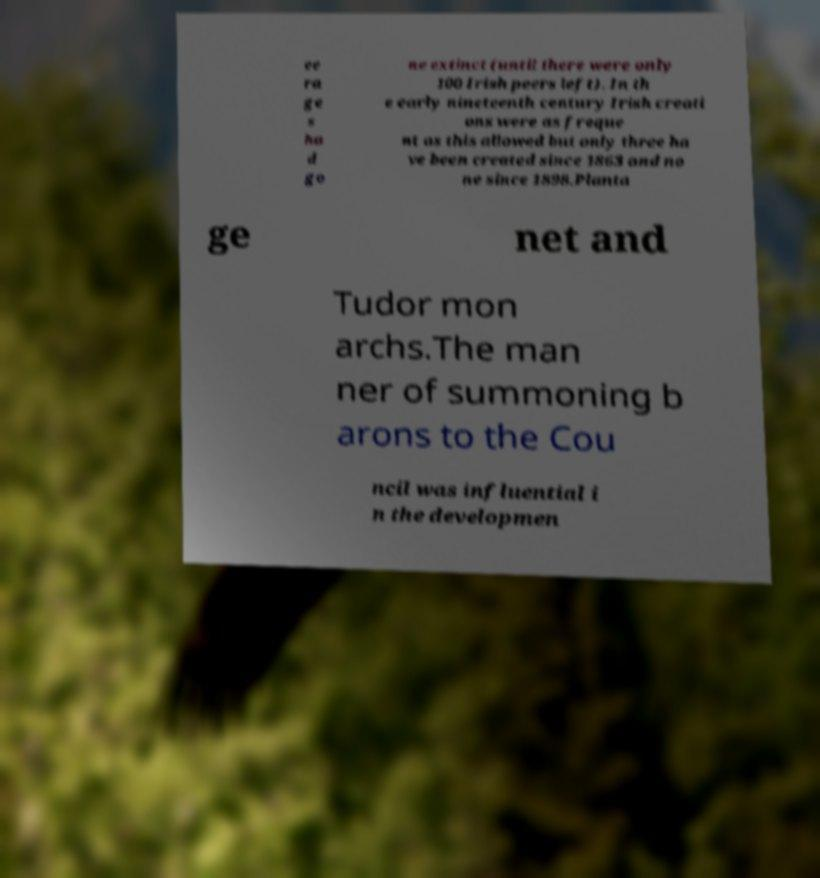Could you assist in decoding the text presented in this image and type it out clearly? ee ra ge s ha d go ne extinct (until there were only 100 Irish peers left). In th e early nineteenth century Irish creati ons were as freque nt as this allowed but only three ha ve been created since 1863 and no ne since 1898.Planta ge net and Tudor mon archs.The man ner of summoning b arons to the Cou ncil was influential i n the developmen 